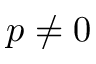Convert formula to latex. <formula><loc_0><loc_0><loc_500><loc_500>p \neq 0</formula> 